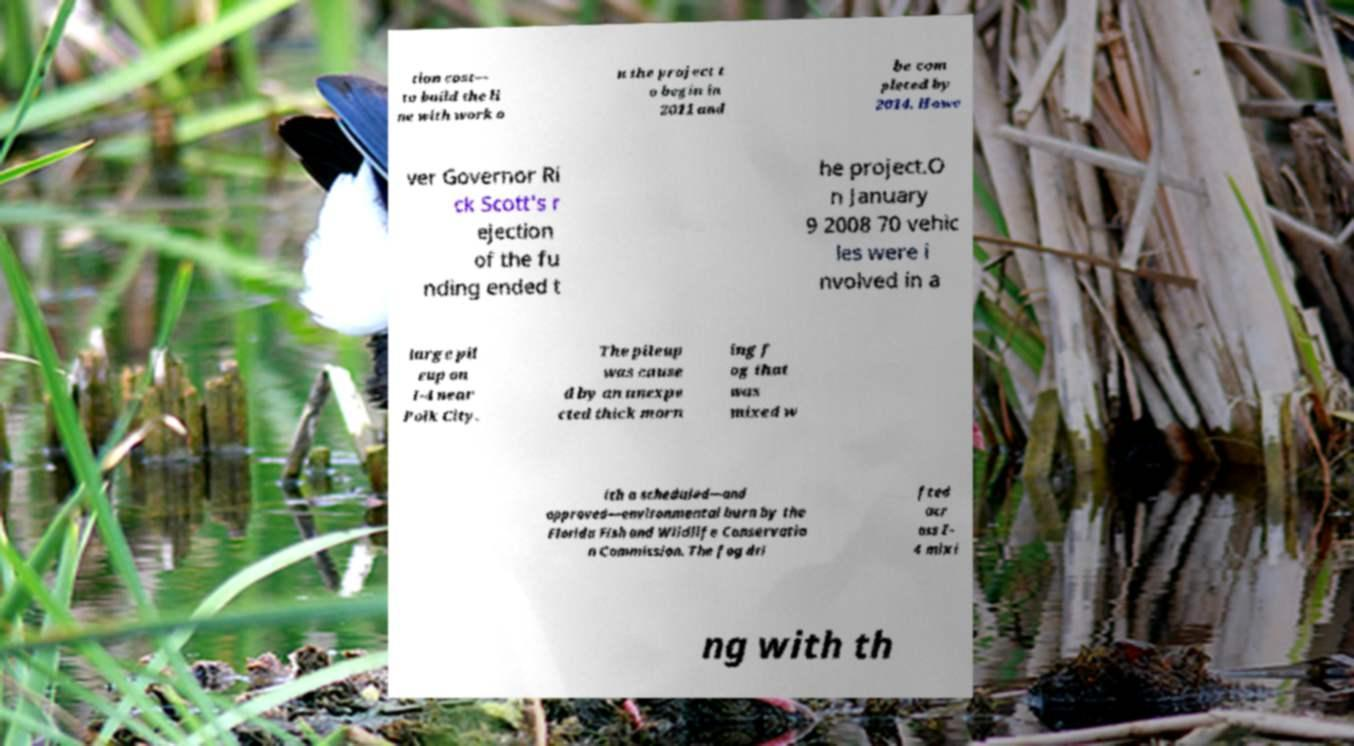What messages or text are displayed in this image? I need them in a readable, typed format. tion cost— to build the li ne with work o n the project t o begin in 2011 and be com pleted by 2014. Howe ver Governor Ri ck Scott's r ejection of the fu nding ended t he project.O n January 9 2008 70 vehic les were i nvolved in a large pil eup on I-4 near Polk City. The pileup was cause d by an unexpe cted thick morn ing f og that was mixed w ith a scheduled—and approved—environmental burn by the Florida Fish and Wildlife Conservatio n Commission. The fog dri fted acr oss I- 4 mixi ng with th 